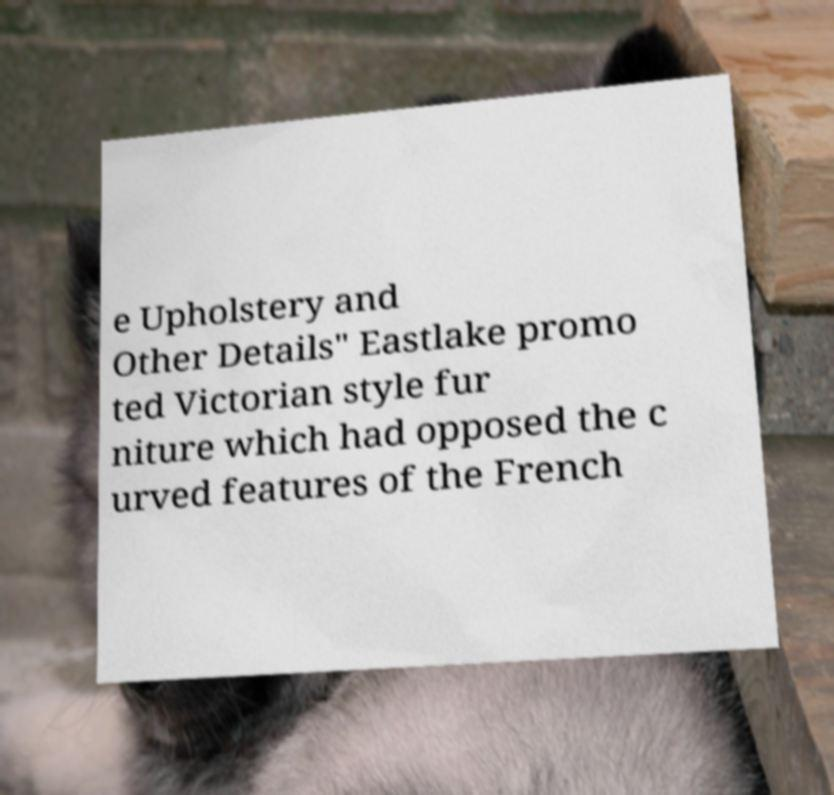For documentation purposes, I need the text within this image transcribed. Could you provide that? e Upholstery and Other Details" Eastlake promo ted Victorian style fur niture which had opposed the c urved features of the French 